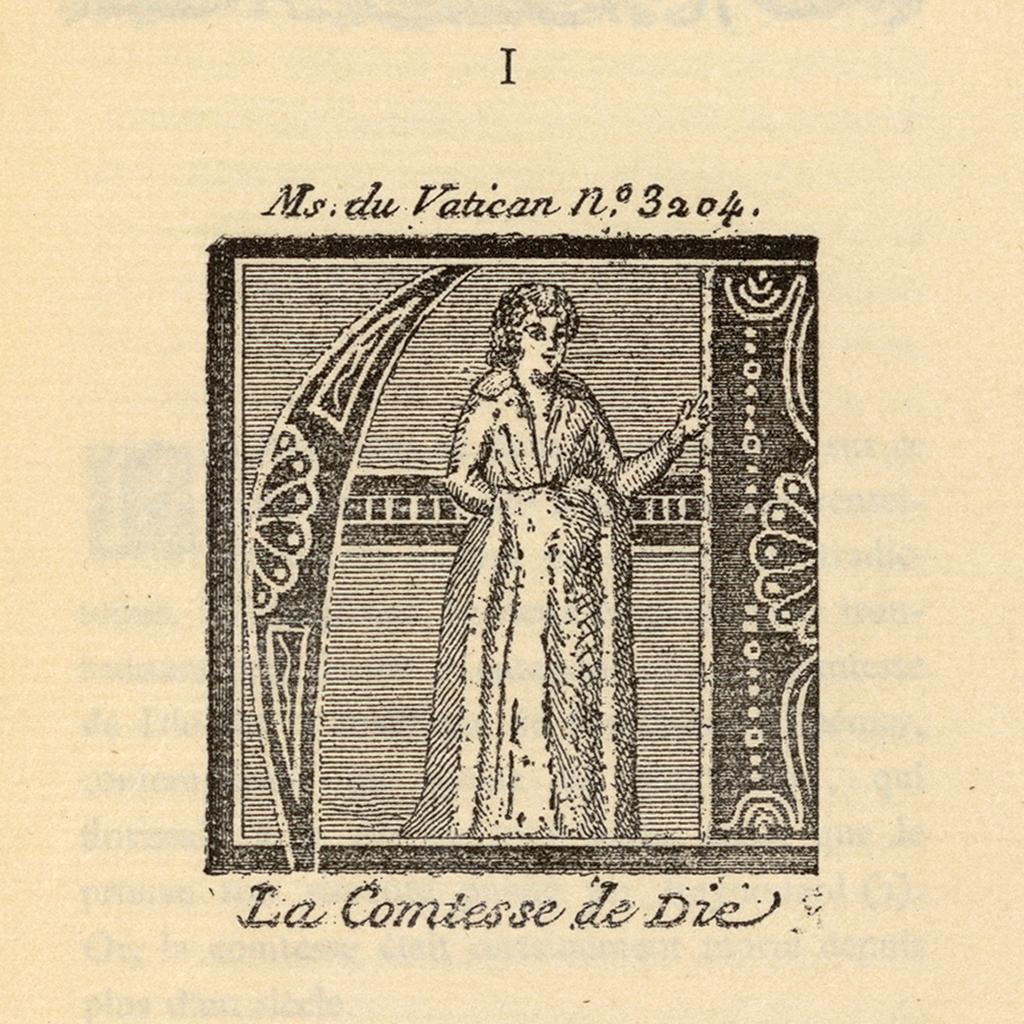Could you give a brief overview of what you see in this image? This image consists of a paper with an image of a woman and there is a text on it. 